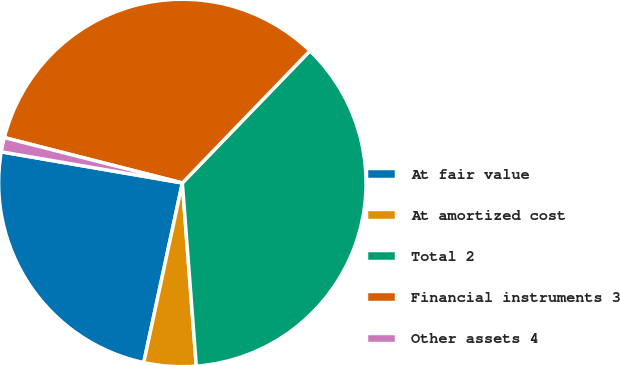Convert chart. <chart><loc_0><loc_0><loc_500><loc_500><pie_chart><fcel>At fair value<fcel>At amortized cost<fcel>Total 2<fcel>Financial instruments 3<fcel>Other assets 4<nl><fcel>24.34%<fcel>4.58%<fcel>36.57%<fcel>33.25%<fcel>1.26%<nl></chart> 